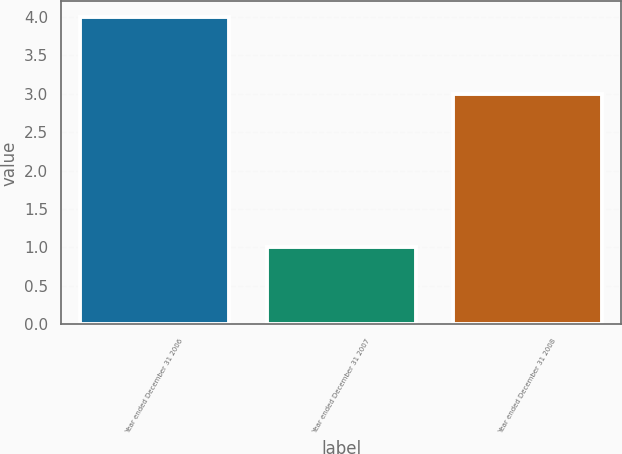<chart> <loc_0><loc_0><loc_500><loc_500><bar_chart><fcel>Year ended December 31 2006<fcel>Year ended December 31 2007<fcel>Year ended December 31 2008<nl><fcel>4<fcel>1<fcel>3<nl></chart> 